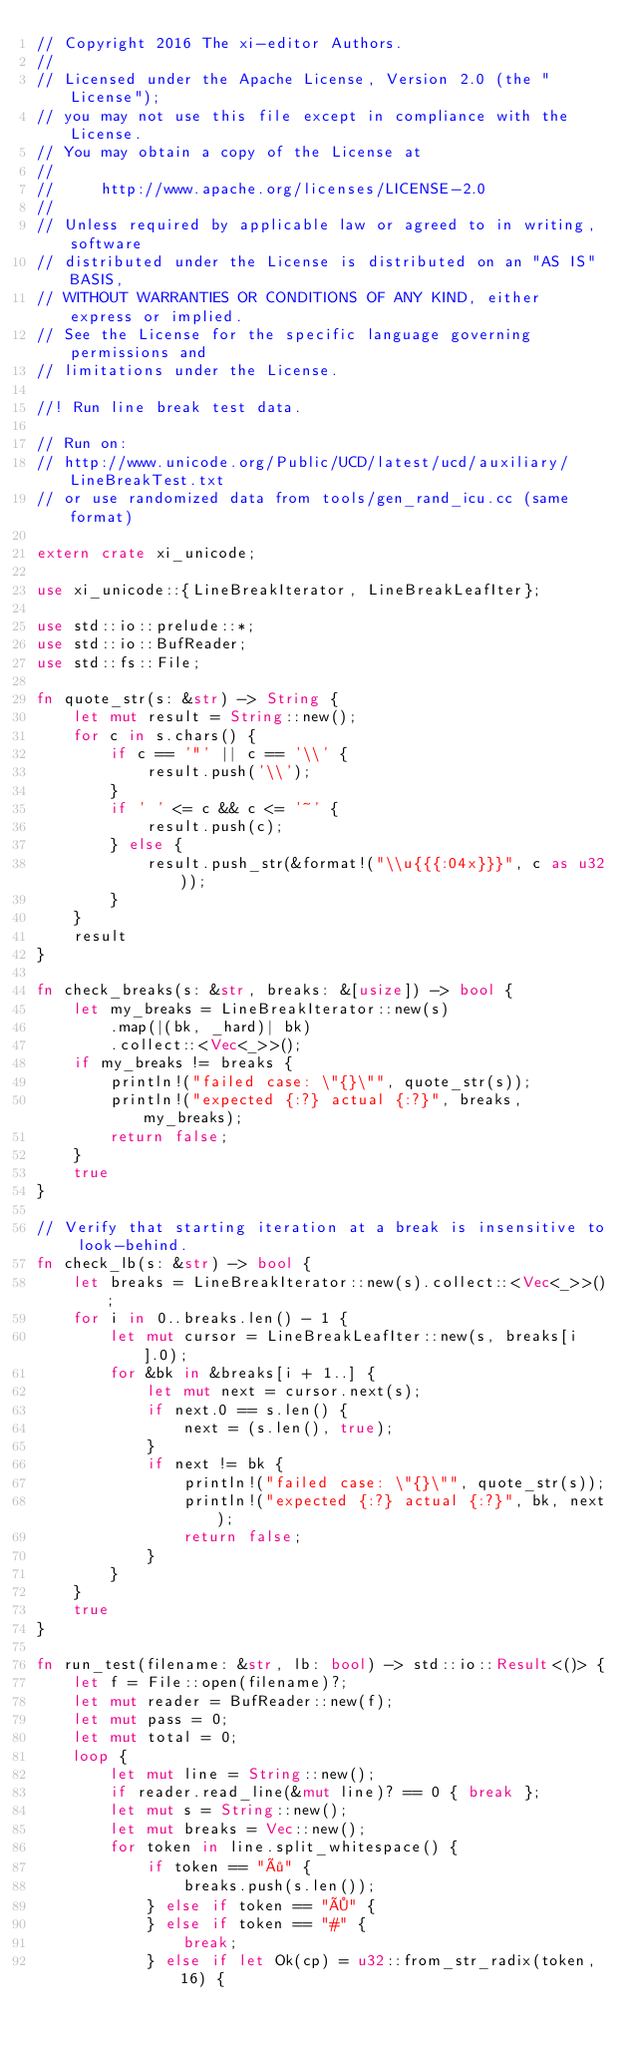<code> <loc_0><loc_0><loc_500><loc_500><_Rust_>// Copyright 2016 The xi-editor Authors.
//
// Licensed under the Apache License, Version 2.0 (the "License");
// you may not use this file except in compliance with the License.
// You may obtain a copy of the License at
//
//     http://www.apache.org/licenses/LICENSE-2.0
//
// Unless required by applicable law or agreed to in writing, software
// distributed under the License is distributed on an "AS IS" BASIS,
// WITHOUT WARRANTIES OR CONDITIONS OF ANY KIND, either express or implied.
// See the License for the specific language governing permissions and
// limitations under the License.

//! Run line break test data.

// Run on:
// http://www.unicode.org/Public/UCD/latest/ucd/auxiliary/LineBreakTest.txt
// or use randomized data from tools/gen_rand_icu.cc (same format)

extern crate xi_unicode;

use xi_unicode::{LineBreakIterator, LineBreakLeafIter};

use std::io::prelude::*;
use std::io::BufReader;
use std::fs::File;

fn quote_str(s: &str) -> String {
    let mut result = String::new();
    for c in s.chars() {
        if c == '"' || c == '\\' {
            result.push('\\');
        }
        if ' ' <= c && c <= '~' {
            result.push(c);
        } else {
            result.push_str(&format!("\\u{{{:04x}}}", c as u32));
        }
    }
    result
}

fn check_breaks(s: &str, breaks: &[usize]) -> bool {
    let my_breaks = LineBreakIterator::new(s)
        .map(|(bk, _hard)| bk)
        .collect::<Vec<_>>();
    if my_breaks != breaks {
        println!("failed case: \"{}\"", quote_str(s));
        println!("expected {:?} actual {:?}", breaks, my_breaks);
        return false;
    }
    true
}

// Verify that starting iteration at a break is insensitive to look-behind.
fn check_lb(s: &str) -> bool {
    let breaks = LineBreakIterator::new(s).collect::<Vec<_>>();
    for i in 0..breaks.len() - 1 {
        let mut cursor = LineBreakLeafIter::new(s, breaks[i].0);
        for &bk in &breaks[i + 1..] {
            let mut next = cursor.next(s);
            if next.0 == s.len() {
                next = (s.len(), true);
            }
            if next != bk {
                println!("failed case: \"{}\"", quote_str(s));
                println!("expected {:?} actual {:?}", bk, next);
                return false;
            }
        }
    }
    true
}

fn run_test(filename: &str, lb: bool) -> std::io::Result<()> {
    let f = File::open(filename)?;
    let mut reader = BufReader::new(f);
    let mut pass = 0;
    let mut total = 0;
    loop {
        let mut line = String::new();
        if reader.read_line(&mut line)? == 0 { break };
        let mut s = String::new();
        let mut breaks = Vec::new();
        for token in line.split_whitespace() {
            if token == "÷" {
                breaks.push(s.len());
            } else if token == "×" {
            } else if token == "#" {
                break;
            } else if let Ok(cp) = u32::from_str_radix(token, 16) {</code> 